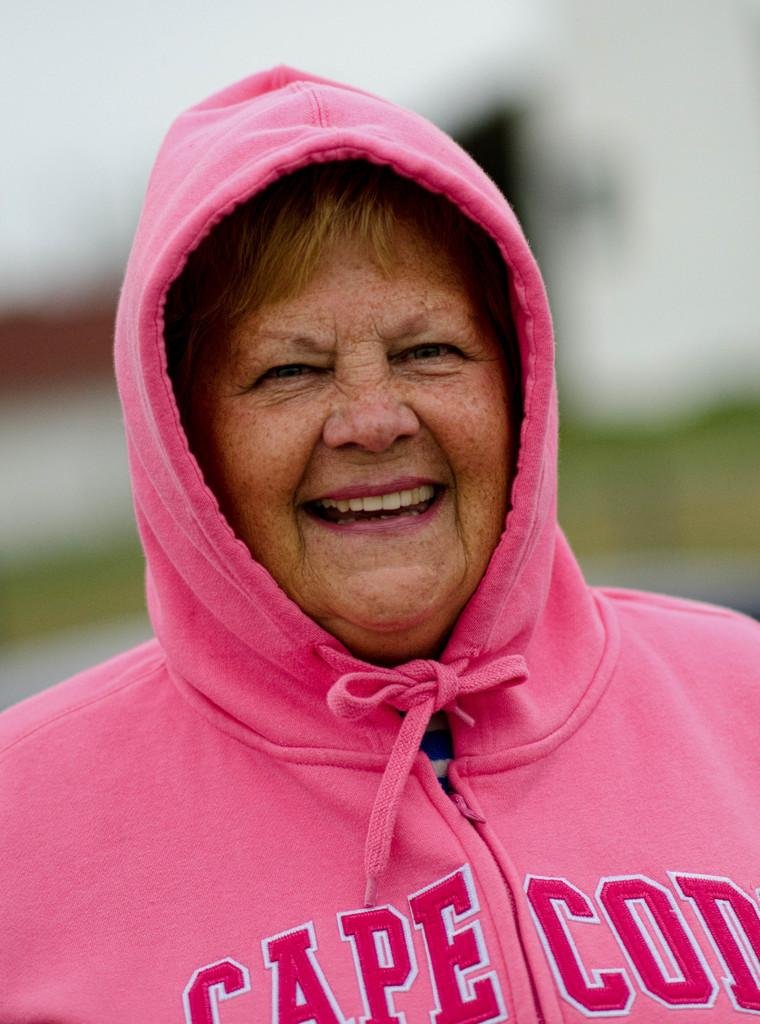Who is the main subject in the image? There is a lady in the image. What is the lady wearing in the image? The lady is wearing a pink jacket. Can you describe the background of the image? The background of the image is blurry. What type of advertisement can be seen on the lady's skirt in the image? There is no skirt present in the image, and therefore no advertisement can be seen on it. What part of the lady's outfit is missing in the image? The image does not show any missing parts of the lady's outfit; it only shows her wearing a pink jacket. 